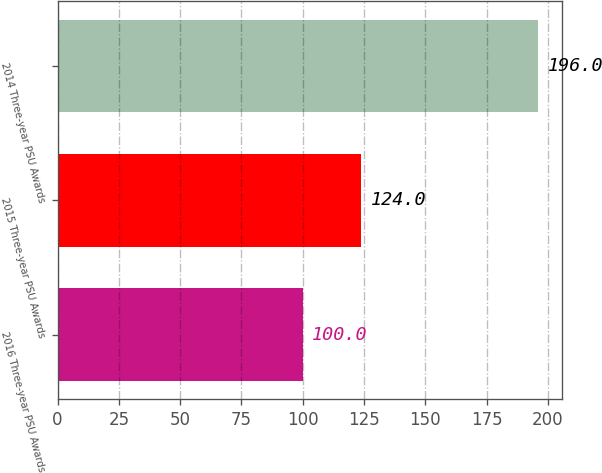<chart> <loc_0><loc_0><loc_500><loc_500><bar_chart><fcel>2016 Three-year PSU Awards<fcel>2015 Three-year PSU Awards<fcel>2014 Three-year PSU Awards<nl><fcel>100<fcel>124<fcel>196<nl></chart> 